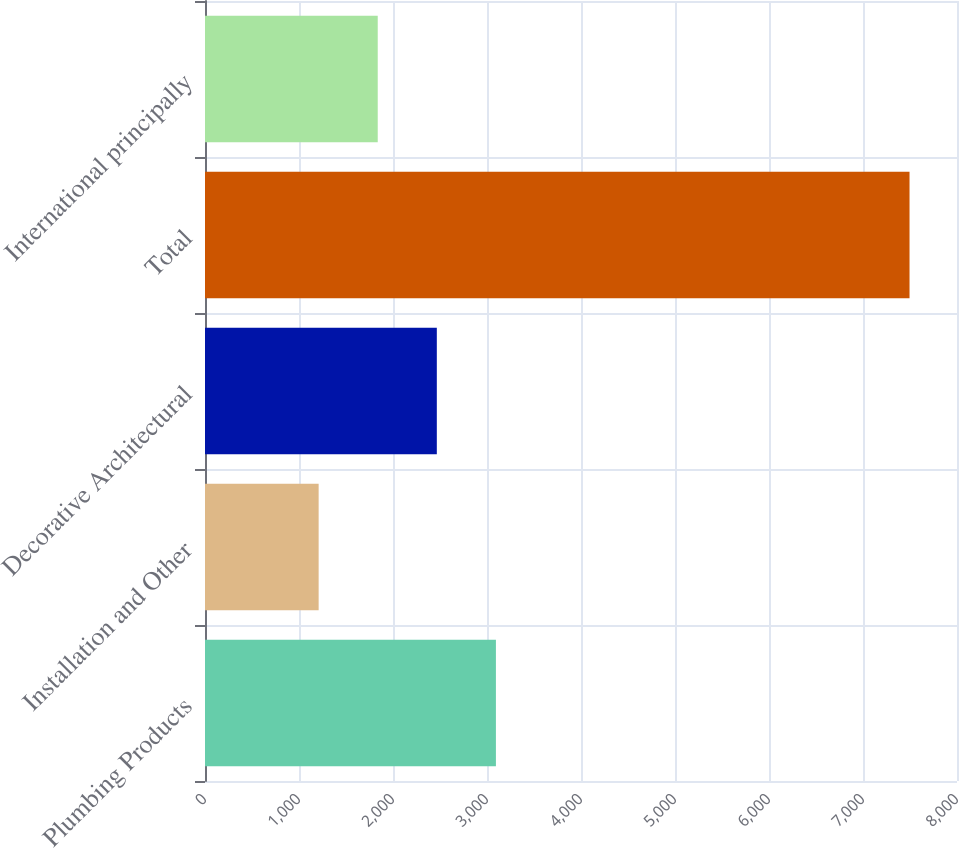<chart> <loc_0><loc_0><loc_500><loc_500><bar_chart><fcel>Plumbing Products<fcel>Installation and Other<fcel>Decorative Architectural<fcel>Total<fcel>International principally<nl><fcel>3094.8<fcel>1209<fcel>2466.2<fcel>7495<fcel>1837.6<nl></chart> 